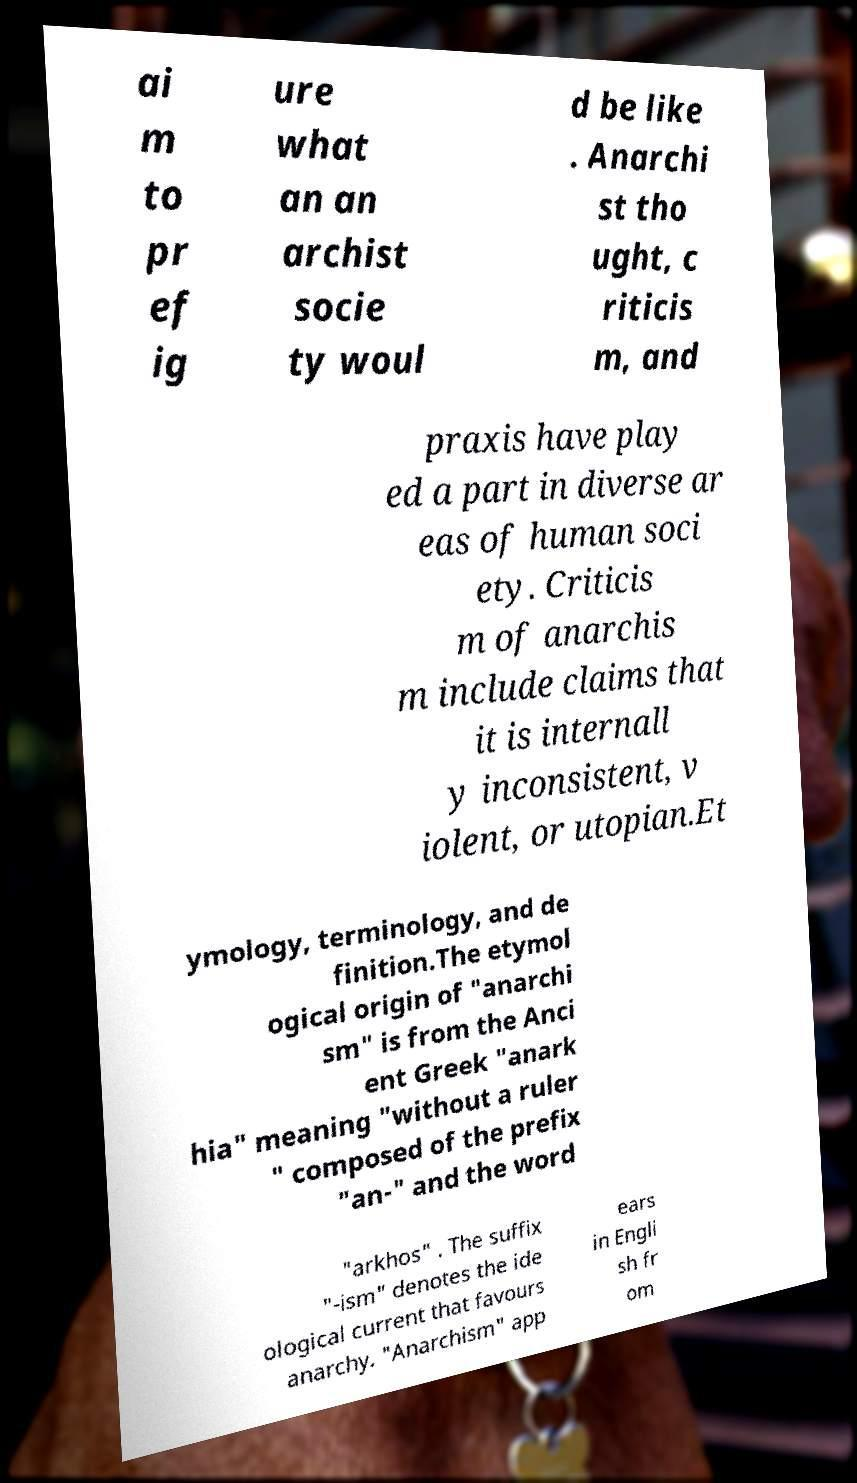Can you accurately transcribe the text from the provided image for me? ai m to pr ef ig ure what an an archist socie ty woul d be like . Anarchi st tho ught, c riticis m, and praxis have play ed a part in diverse ar eas of human soci ety. Criticis m of anarchis m include claims that it is internall y inconsistent, v iolent, or utopian.Et ymology, terminology, and de finition.The etymol ogical origin of "anarchi sm" is from the Anci ent Greek "anark hia" meaning "without a ruler " composed of the prefix "an-" and the word "arkhos" . The suffix "-ism" denotes the ide ological current that favours anarchy. "Anarchism" app ears in Engli sh fr om 